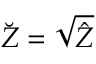Convert formula to latex. <formula><loc_0><loc_0><loc_500><loc_500>\breve { Z } = \sqrt { \hat { Z } }</formula> 